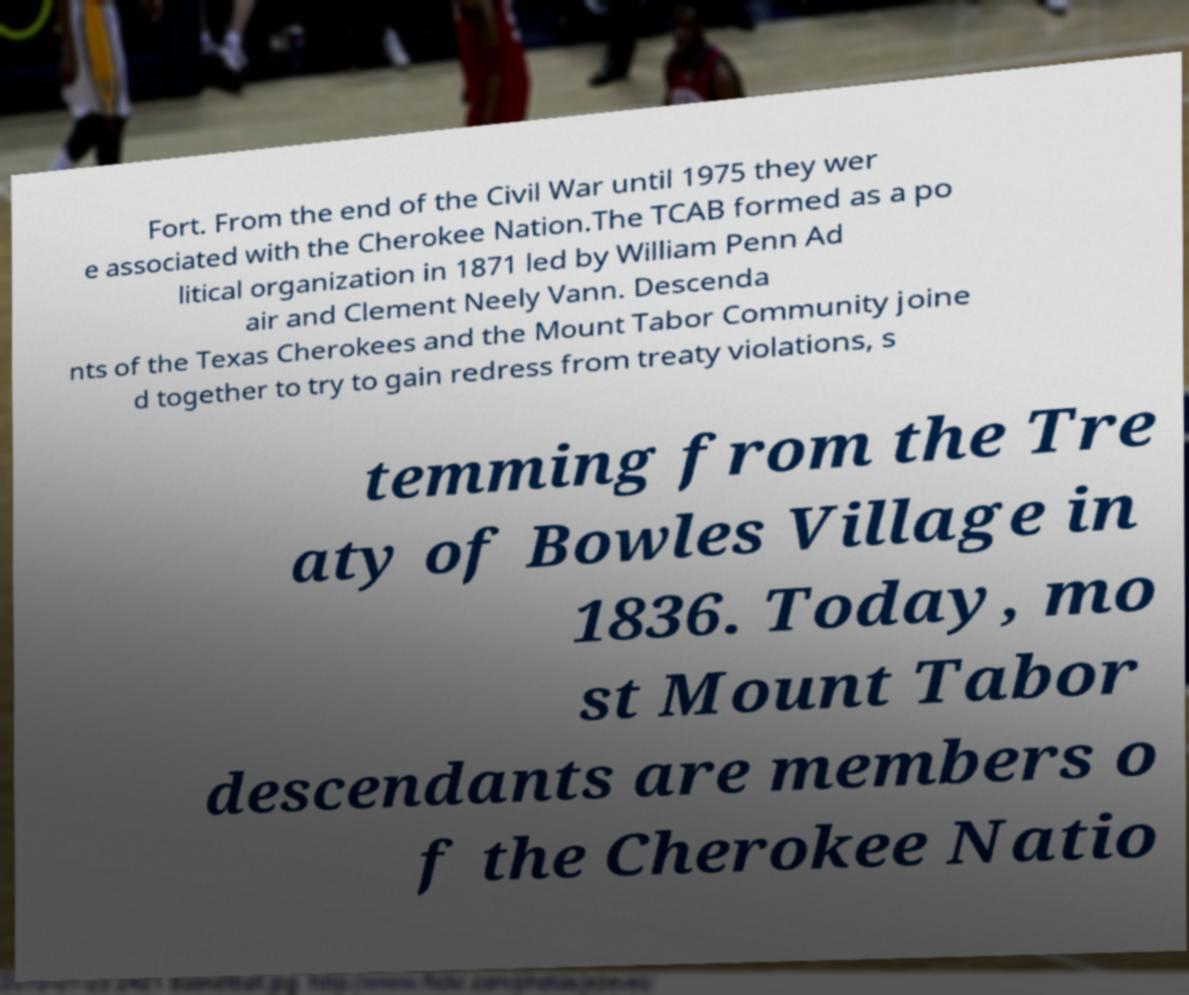Can you read and provide the text displayed in the image?This photo seems to have some interesting text. Can you extract and type it out for me? Fort. From the end of the Civil War until 1975 they wer e associated with the Cherokee Nation.The TCAB formed as a po litical organization in 1871 led by William Penn Ad air and Clement Neely Vann. Descenda nts of the Texas Cherokees and the Mount Tabor Community joine d together to try to gain redress from treaty violations, s temming from the Tre aty of Bowles Village in 1836. Today, mo st Mount Tabor descendants are members o f the Cherokee Natio 